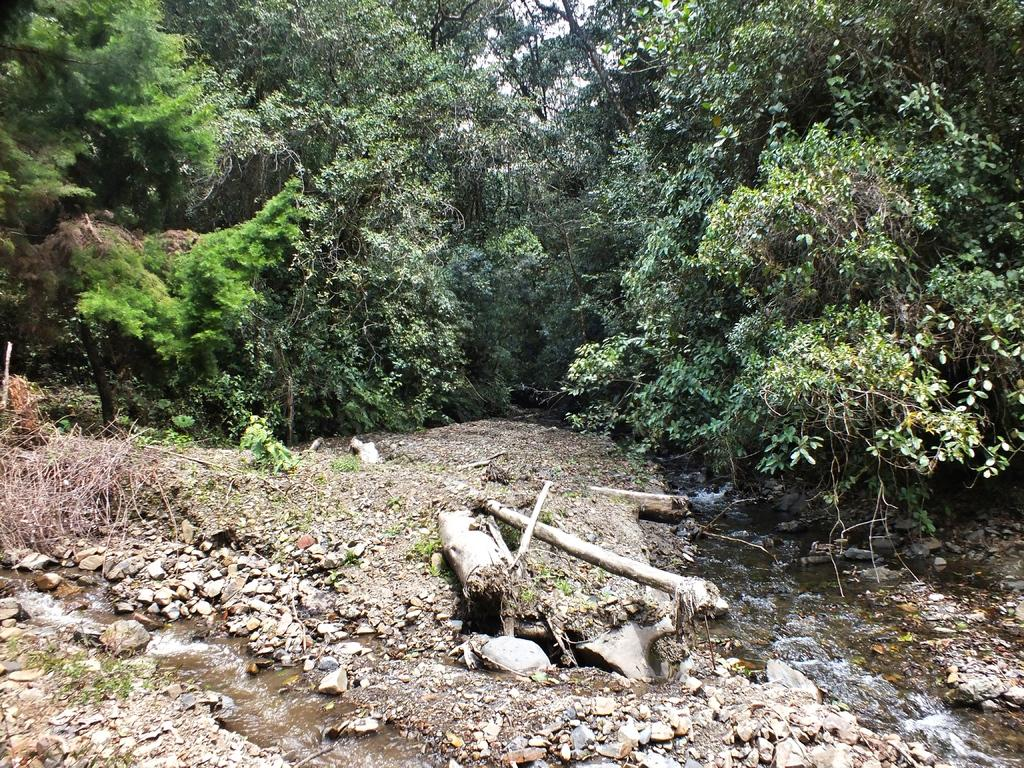What can be seen on the ground in the front of the image? There are stones on the ground in the front of the image. What is visible in the background of the image? There are trees in the background of the image. What is present in the front of the image besides the stones? There is water visible in the front of the image. What type of vegetation can be seen in the image? There is dry grass in the image. Can you tell me what type of prose is being recited by the cactus in the image? There is no cactus or prose present in the image. How many fingers can be seen pointing at the dry grass in the image? There are no fingers visible in the image; it only shows stones, water, trees, and dry grass. 